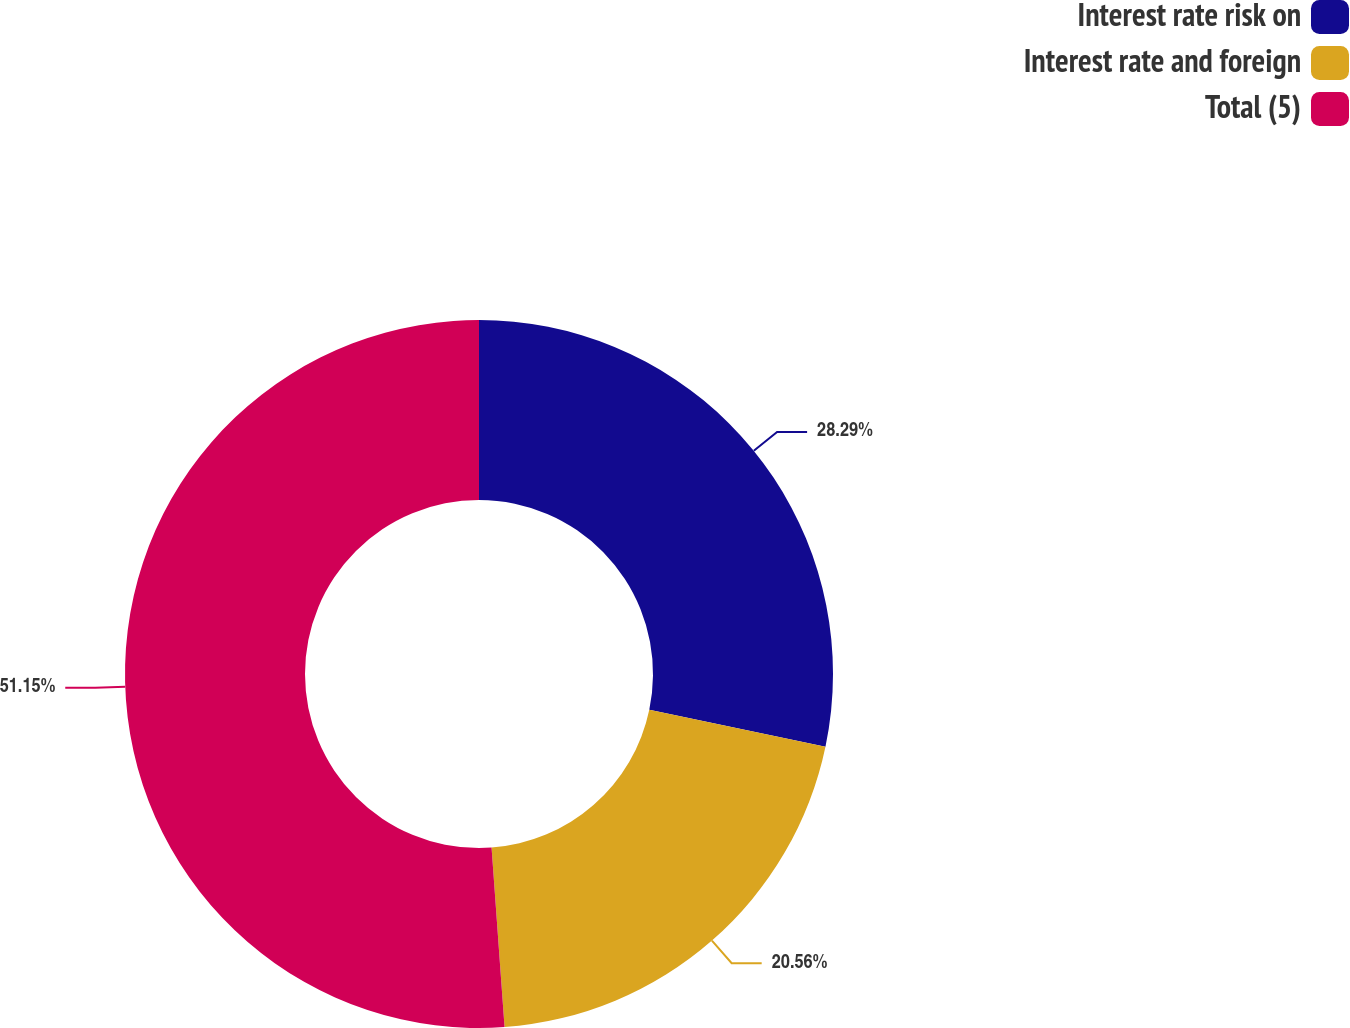Convert chart to OTSL. <chart><loc_0><loc_0><loc_500><loc_500><pie_chart><fcel>Interest rate risk on<fcel>Interest rate and foreign<fcel>Total (5)<nl><fcel>28.29%<fcel>20.56%<fcel>51.15%<nl></chart> 